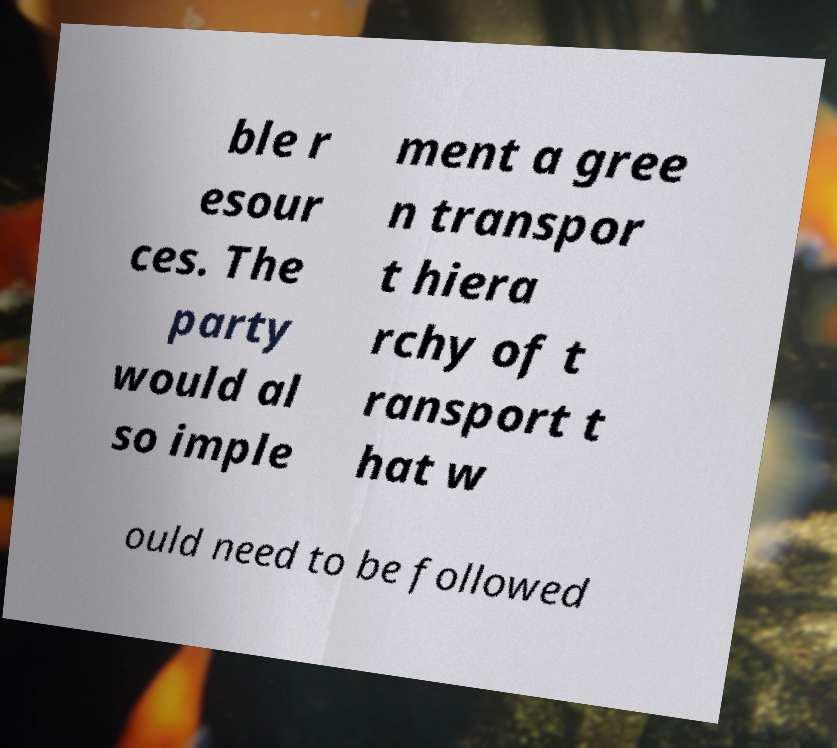What messages or text are displayed in this image? I need them in a readable, typed format. ble r esour ces. The party would al so imple ment a gree n transpor t hiera rchy of t ransport t hat w ould need to be followed 